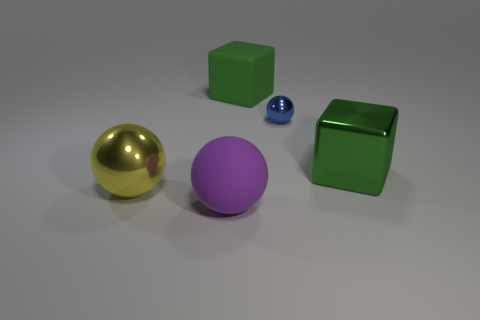There is a green matte thing; are there any tiny blue metallic balls behind it?
Offer a very short reply. No. How many tiny blue shiny objects have the same shape as the large yellow shiny object?
Your answer should be compact. 1. Are the tiny object and the large green cube that is in front of the blue sphere made of the same material?
Your response must be concise. Yes. How many big yellow balls are there?
Give a very brief answer. 1. There is a green block in front of the tiny metallic thing; what size is it?
Your response must be concise. Large. How many green objects have the same size as the blue metal ball?
Make the answer very short. 0. There is a object that is to the right of the purple object and in front of the blue metallic ball; what material is it?
Provide a succinct answer. Metal. What is the material of the other cube that is the same size as the metal block?
Ensure brevity in your answer.  Rubber. What is the size of the rubber object that is in front of the large green metallic cube that is behind the metallic sphere that is on the left side of the large purple object?
Offer a terse response. Large. What size is the cube that is made of the same material as the large purple object?
Offer a very short reply. Large. 